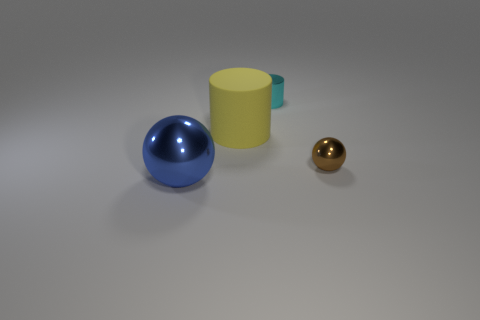Add 4 blue balls. How many objects exist? 8 Add 1 small purple shiny cubes. How many small purple shiny cubes exist? 1 Subtract 0 green cylinders. How many objects are left? 4 Subtract all cyan metal objects. Subtract all big green metal cubes. How many objects are left? 3 Add 2 brown metal spheres. How many brown metal spheres are left? 3 